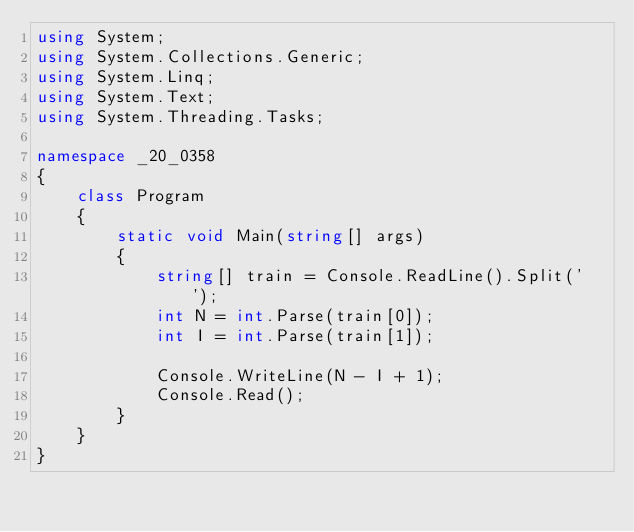Convert code to text. <code><loc_0><loc_0><loc_500><loc_500><_C#_>using System;
using System.Collections.Generic;
using System.Linq;
using System.Text;
using System.Threading.Tasks;

namespace _20_0358
{
    class Program
    {
        static void Main(string[] args)
        {
            string[] train = Console.ReadLine().Split(' ');
            int N = int.Parse(train[0]);
            int I = int.Parse(train[1]);

            Console.WriteLine(N - I + 1);
            Console.Read();
        }
    }
}
</code> 